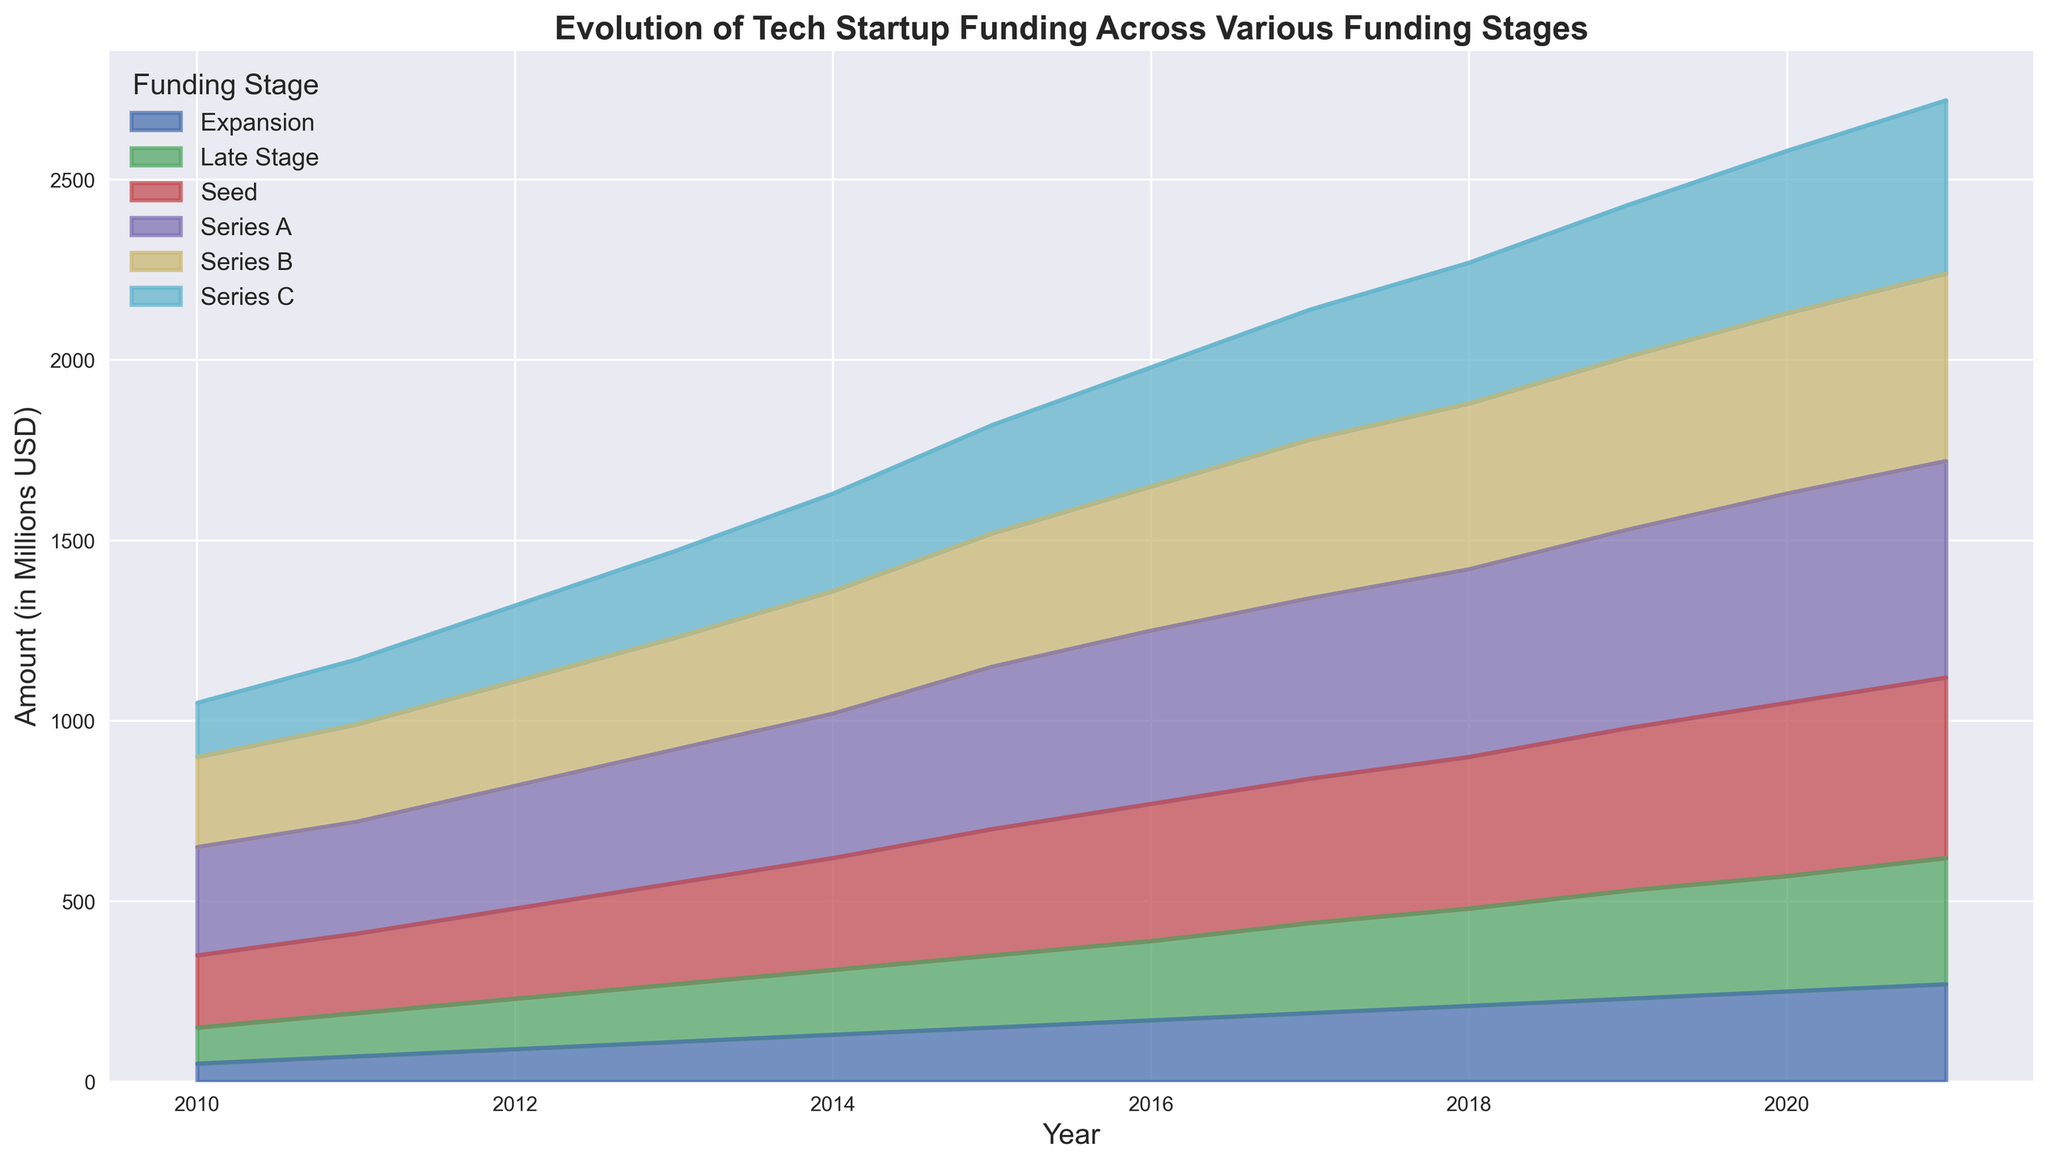What trend do you observe in the funding amount for the Seed stage from 2010 to 2021? To determine the trend, observe the overall direction of the Seed stage area in the chart from 2010 to 2021. The area increases steadily over the years, indicating a continual rise in funding.
Answer: Increasing Which funding stage had the highest funding amount in 2015? By comparing the height of all the areas at the year 2015, it is evident that the Series A funding stage has the highest funding amount as its area is the largest at that point.
Answer: Series A Compare the total funding amount between Series B and Series C stages in 2021. Locate the 2021 funding amounts for both Series B (520 million USD) and Series C (480 million USD). By summing them, we get Series B + Series C = 520 + 480 = 1000 million USD.
Answer: 1000 million USD Which funding stage shows the steepest growth rate between 2010 and 2013? The steepest growth rate can be identified by looking for the area that expands the most between 2010 and 2013. The Late Stage funding increases from 100 to 160, which is a 60% increase and appears steeper compared to other funding stages.
Answer: Late Stage Are there any funding stages that display a plateau in funding amounts over a certain period? Search for any periods where the areas flatten out, indicating little to no change in funding. The Seed stage shows a slight plateau between 2016 and 2017 where funding amounts remain similar.
Answer: Seed How does the amount of Late Stage funding in 2018 compare to that of Expansion funding in the same year? Locate the funding amounts for Late Stage (270 million USD) and Expansion (210 million USD) in 2018. The Late Stage funding is higher.
Answer: Late Stage What is the approximate combined funding amount for Seed, Series A, and Series B stages in 2011? Identify the funding amounts for Seed (220 million USD), Series A (310 million USD), and Series B (270 million USD) in 2011. Add them: 220 + 310 + 270 = 800 million USD.
Answer: 800 million USD Which funding stage shows the most consistent growth over the years? Consistent growth can be determined by finding the stage area that grows steadily without large fluctuations. Series A funding appears to grow consistently from 2010 to 2021 without sharp increases or decreases.
Answer: Series A At what year does the combined funding for all stages seem to reach a peak? To find this, observe the overall height of the combined areas across the years. The maximum overall height appears to be in 2021.
Answer: 2021 Which funding stage has the lowest funding amount in 2010? By comparing the initial points of all areas in 2010, the Expansion stage has the lowest funding amount at 50 million USD.
Answer: Expansion 